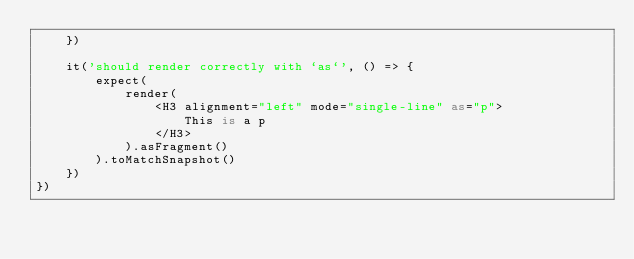<code> <loc_0><loc_0><loc_500><loc_500><_TypeScript_>    })

    it('should render correctly with `as`', () => {
        expect(
            render(
                <H3 alignment="left" mode="single-line" as="p">
                    This is a p
                </H3>
            ).asFragment()
        ).toMatchSnapshot()
    })
})
</code> 